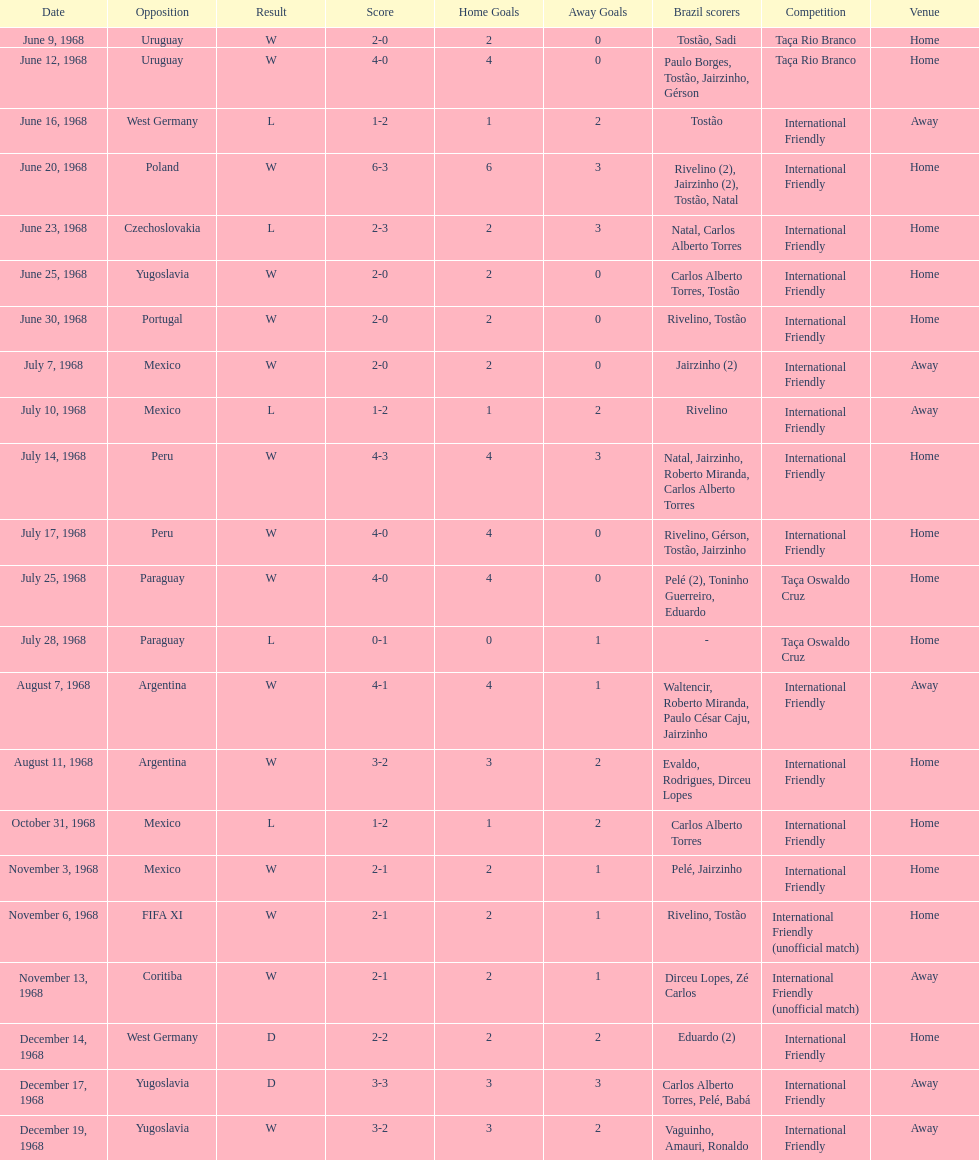How many times did brazil play against argentina in the international friendly competition? 2. 